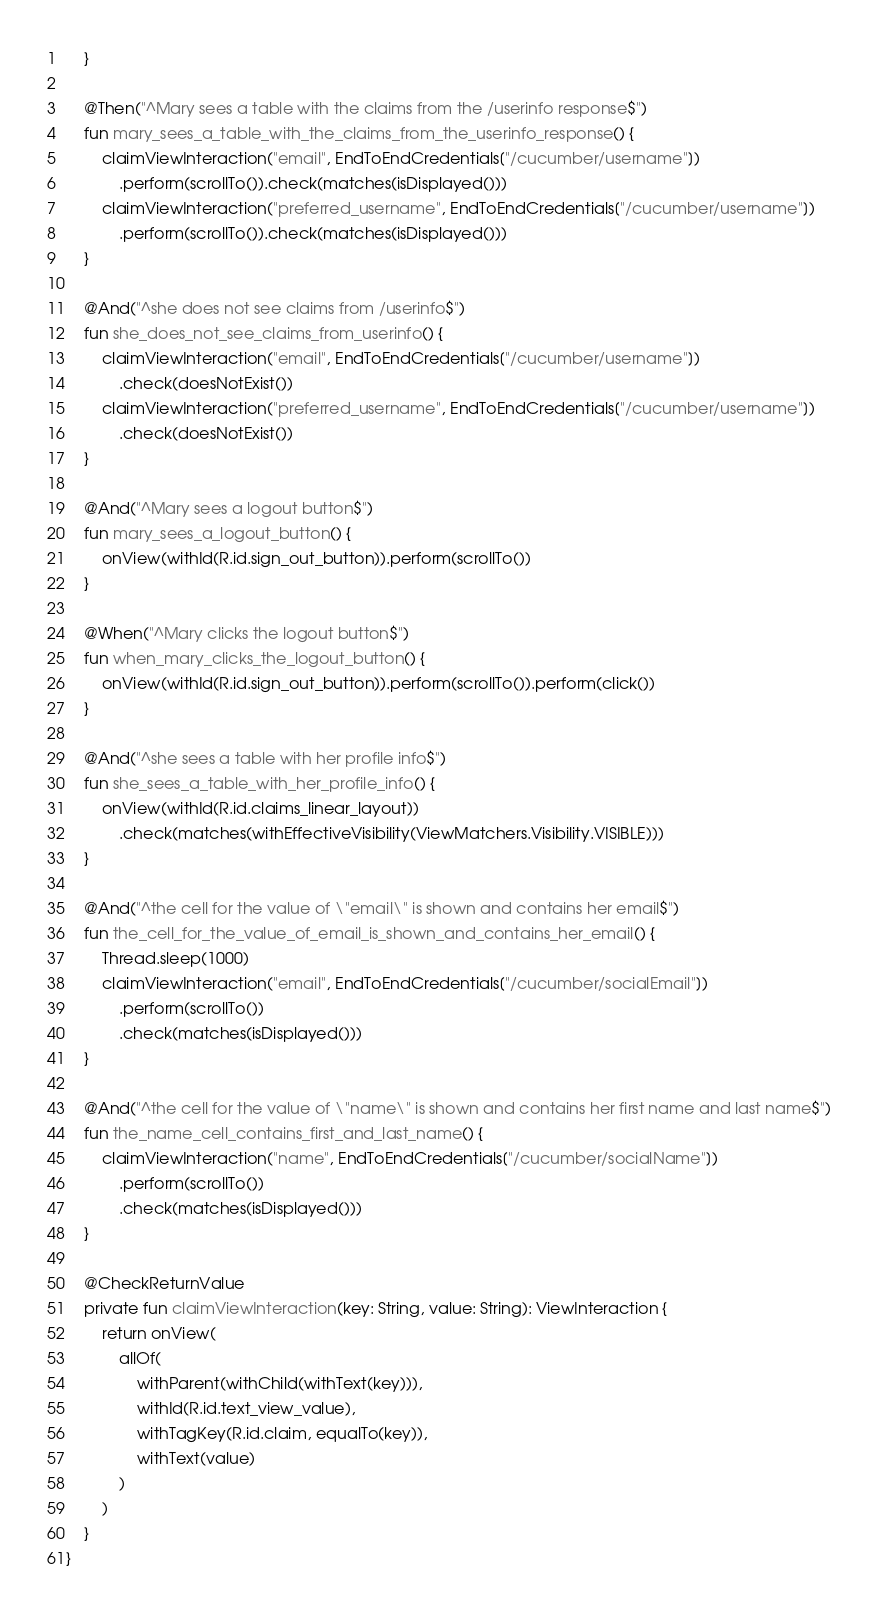Convert code to text. <code><loc_0><loc_0><loc_500><loc_500><_Kotlin_>    }

    @Then("^Mary sees a table with the claims from the /userinfo response$")
    fun mary_sees_a_table_with_the_claims_from_the_userinfo_response() {
        claimViewInteraction("email", EndToEndCredentials["/cucumber/username"])
            .perform(scrollTo()).check(matches(isDisplayed()))
        claimViewInteraction("preferred_username", EndToEndCredentials["/cucumber/username"])
            .perform(scrollTo()).check(matches(isDisplayed()))
    }

    @And("^she does not see claims from /userinfo$")
    fun she_does_not_see_claims_from_userinfo() {
        claimViewInteraction("email", EndToEndCredentials["/cucumber/username"])
            .check(doesNotExist())
        claimViewInteraction("preferred_username", EndToEndCredentials["/cucumber/username"])
            .check(doesNotExist())
    }

    @And("^Mary sees a logout button$")
    fun mary_sees_a_logout_button() {
        onView(withId(R.id.sign_out_button)).perform(scrollTo())
    }

    @When("^Mary clicks the logout button$")
    fun when_mary_clicks_the_logout_button() {
        onView(withId(R.id.sign_out_button)).perform(scrollTo()).perform(click())
    }

    @And("^she sees a table with her profile info$")
    fun she_sees_a_table_with_her_profile_info() {
        onView(withId(R.id.claims_linear_layout))
            .check(matches(withEffectiveVisibility(ViewMatchers.Visibility.VISIBLE)))
    }

    @And("^the cell for the value of \"email\" is shown and contains her email$")
    fun the_cell_for_the_value_of_email_is_shown_and_contains_her_email() {
        Thread.sleep(1000)
        claimViewInteraction("email", EndToEndCredentials["/cucumber/socialEmail"])
            .perform(scrollTo())
            .check(matches(isDisplayed()))
    }

    @And("^the cell for the value of \"name\" is shown and contains her first name and last name$")
    fun the_name_cell_contains_first_and_last_name() {
        claimViewInteraction("name", EndToEndCredentials["/cucumber/socialName"])
            .perform(scrollTo())
            .check(matches(isDisplayed()))
    }

    @CheckReturnValue
    private fun claimViewInteraction(key: String, value: String): ViewInteraction {
        return onView(
            allOf(
                withParent(withChild(withText(key))),
                withId(R.id.text_view_value),
                withTagKey(R.id.claim, equalTo(key)),
                withText(value)
            )
        )
    }
}
</code> 